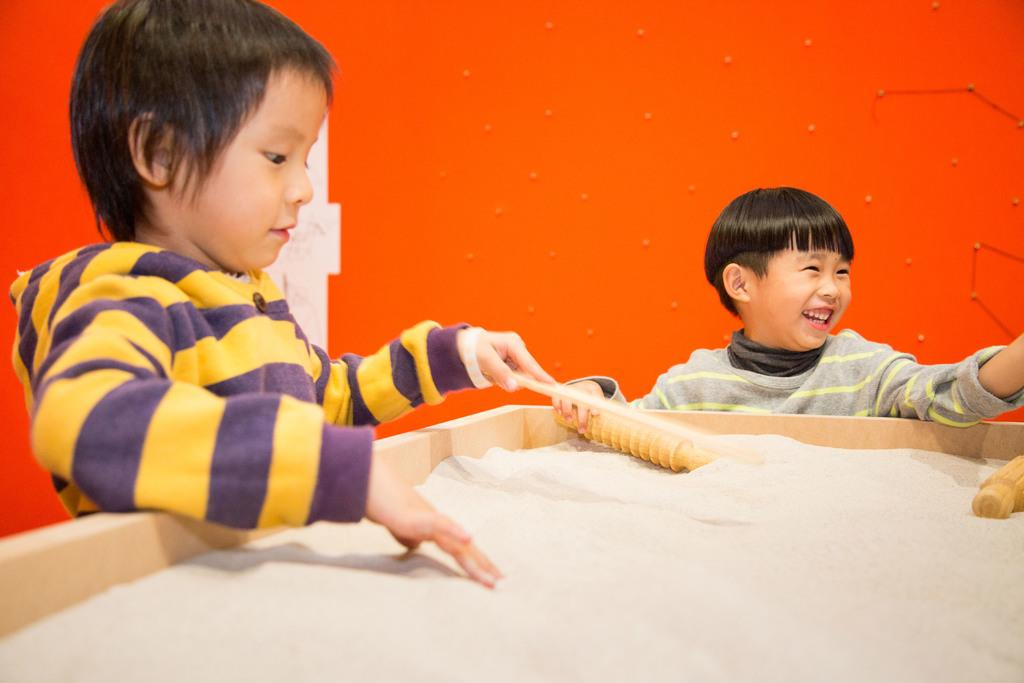What are the kids doing in the image? The kids are standing and holding sticks in the image. What might the kids be using the sticks for? It is unclear what the kids are using the sticks for, but they are holding them in their hands. What is in the wooden box in the image? There is sand in a wooden box in the image. What can be seen in the background of the image? There is a wall in the background of the image. What type of belief is depicted on the wall in the image? There is no indication of any belief being depicted on the wall in the image; it is simply a wall in the background. 